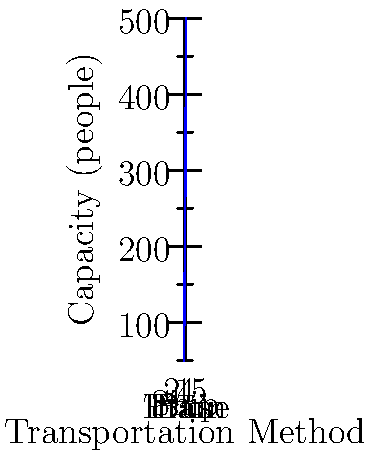As an immigration lawyer, you're assisting in planning a large-scale relocation of refugees. Based on the graph showing the capacity of different transportation methods, what is the total number of people that can be transported using one of each method? To solve this problem, we need to:

1. Identify the capacity of each transportation method from the graph:
   - Bus: 50 people
   - Train: 150 people
   - Ship: 300 people
   - Plane: 500 people

2. Sum up the capacities:
   $50 + 150 + 300 + 500 = 1000$

Therefore, using one of each transportation method, we can relocate a total of 1000 refugees.

This calculation is crucial for immigration lawyers when advising on large-scale relocation projects, as it helps in logistical planning and ensures compliance with immigration regulations regarding the number of people that can be moved at once.
Answer: 1000 people 